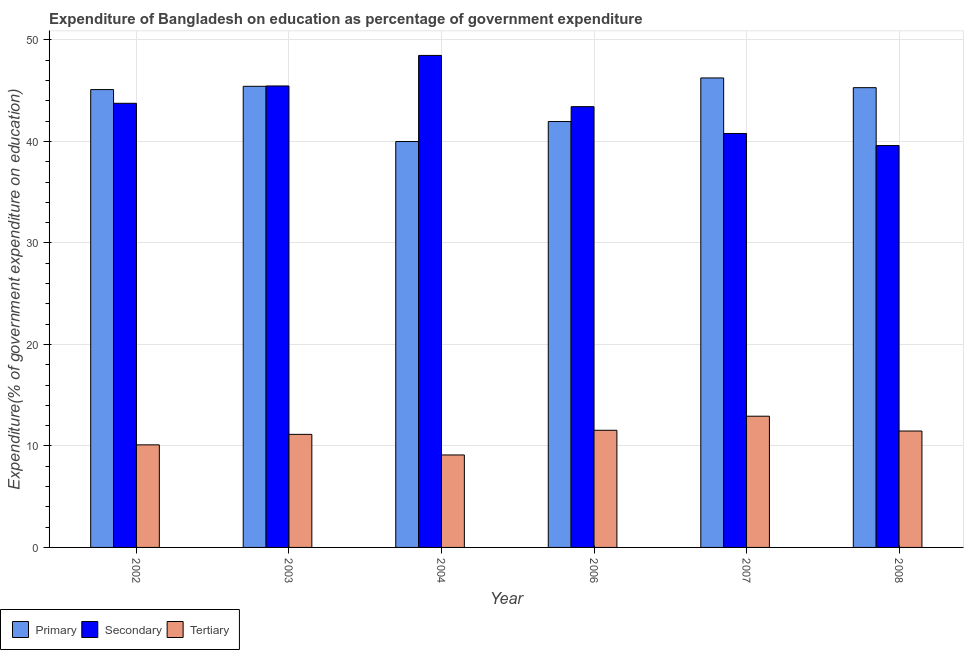How many different coloured bars are there?
Provide a succinct answer. 3. How many groups of bars are there?
Offer a very short reply. 6. Are the number of bars per tick equal to the number of legend labels?
Ensure brevity in your answer.  Yes. How many bars are there on the 3rd tick from the left?
Your answer should be very brief. 3. How many bars are there on the 1st tick from the right?
Your response must be concise. 3. What is the expenditure on primary education in 2008?
Offer a very short reply. 45.29. Across all years, what is the maximum expenditure on secondary education?
Provide a short and direct response. 48.47. Across all years, what is the minimum expenditure on secondary education?
Provide a succinct answer. 39.59. In which year was the expenditure on tertiary education minimum?
Make the answer very short. 2004. What is the total expenditure on secondary education in the graph?
Your answer should be compact. 261.48. What is the difference between the expenditure on tertiary education in 2004 and that in 2008?
Give a very brief answer. -2.36. What is the difference between the expenditure on secondary education in 2007 and the expenditure on primary education in 2008?
Provide a short and direct response. 1.19. What is the average expenditure on secondary education per year?
Offer a very short reply. 43.58. What is the ratio of the expenditure on tertiary education in 2007 to that in 2008?
Keep it short and to the point. 1.13. Is the difference between the expenditure on tertiary education in 2002 and 2004 greater than the difference between the expenditure on secondary education in 2002 and 2004?
Provide a short and direct response. No. What is the difference between the highest and the second highest expenditure on primary education?
Your answer should be compact. 0.82. What is the difference between the highest and the lowest expenditure on primary education?
Ensure brevity in your answer.  6.26. Is the sum of the expenditure on primary education in 2003 and 2008 greater than the maximum expenditure on secondary education across all years?
Keep it short and to the point. Yes. What does the 2nd bar from the left in 2006 represents?
Offer a very short reply. Secondary. What does the 3rd bar from the right in 2008 represents?
Keep it short and to the point. Primary. Are the values on the major ticks of Y-axis written in scientific E-notation?
Make the answer very short. No. Does the graph contain any zero values?
Provide a short and direct response. No. Does the graph contain grids?
Make the answer very short. Yes. Where does the legend appear in the graph?
Provide a succinct answer. Bottom left. How many legend labels are there?
Your response must be concise. 3. What is the title of the graph?
Keep it short and to the point. Expenditure of Bangladesh on education as percentage of government expenditure. What is the label or title of the Y-axis?
Provide a succinct answer. Expenditure(% of government expenditure on education). What is the Expenditure(% of government expenditure on education) in Primary in 2002?
Give a very brief answer. 45.11. What is the Expenditure(% of government expenditure on education) of Secondary in 2002?
Provide a short and direct response. 43.76. What is the Expenditure(% of government expenditure on education) in Tertiary in 2002?
Give a very brief answer. 10.11. What is the Expenditure(% of government expenditure on education) in Primary in 2003?
Provide a short and direct response. 45.43. What is the Expenditure(% of government expenditure on education) of Secondary in 2003?
Provide a succinct answer. 45.46. What is the Expenditure(% of government expenditure on education) of Tertiary in 2003?
Provide a short and direct response. 11.14. What is the Expenditure(% of government expenditure on education) in Primary in 2004?
Offer a terse response. 39.99. What is the Expenditure(% of government expenditure on education) of Secondary in 2004?
Ensure brevity in your answer.  48.47. What is the Expenditure(% of government expenditure on education) of Tertiary in 2004?
Offer a terse response. 9.11. What is the Expenditure(% of government expenditure on education) of Primary in 2006?
Offer a very short reply. 41.96. What is the Expenditure(% of government expenditure on education) in Secondary in 2006?
Your answer should be compact. 43.42. What is the Expenditure(% of government expenditure on education) of Tertiary in 2006?
Provide a short and direct response. 11.54. What is the Expenditure(% of government expenditure on education) in Primary in 2007?
Your answer should be compact. 46.25. What is the Expenditure(% of government expenditure on education) in Secondary in 2007?
Your answer should be compact. 40.78. What is the Expenditure(% of government expenditure on education) in Tertiary in 2007?
Keep it short and to the point. 12.93. What is the Expenditure(% of government expenditure on education) in Primary in 2008?
Keep it short and to the point. 45.29. What is the Expenditure(% of government expenditure on education) in Secondary in 2008?
Offer a very short reply. 39.59. What is the Expenditure(% of government expenditure on education) in Tertiary in 2008?
Make the answer very short. 11.47. Across all years, what is the maximum Expenditure(% of government expenditure on education) in Primary?
Give a very brief answer. 46.25. Across all years, what is the maximum Expenditure(% of government expenditure on education) of Secondary?
Keep it short and to the point. 48.47. Across all years, what is the maximum Expenditure(% of government expenditure on education) of Tertiary?
Provide a succinct answer. 12.93. Across all years, what is the minimum Expenditure(% of government expenditure on education) of Primary?
Offer a terse response. 39.99. Across all years, what is the minimum Expenditure(% of government expenditure on education) of Secondary?
Your response must be concise. 39.59. Across all years, what is the minimum Expenditure(% of government expenditure on education) of Tertiary?
Offer a very short reply. 9.11. What is the total Expenditure(% of government expenditure on education) in Primary in the graph?
Offer a terse response. 264.02. What is the total Expenditure(% of government expenditure on education) of Secondary in the graph?
Make the answer very short. 261.48. What is the total Expenditure(% of government expenditure on education) of Tertiary in the graph?
Keep it short and to the point. 66.29. What is the difference between the Expenditure(% of government expenditure on education) in Primary in 2002 and that in 2003?
Your response must be concise. -0.32. What is the difference between the Expenditure(% of government expenditure on education) in Secondary in 2002 and that in 2003?
Ensure brevity in your answer.  -1.71. What is the difference between the Expenditure(% of government expenditure on education) of Tertiary in 2002 and that in 2003?
Provide a short and direct response. -1.03. What is the difference between the Expenditure(% of government expenditure on education) of Primary in 2002 and that in 2004?
Provide a short and direct response. 5.12. What is the difference between the Expenditure(% of government expenditure on education) in Secondary in 2002 and that in 2004?
Provide a succinct answer. -4.71. What is the difference between the Expenditure(% of government expenditure on education) of Primary in 2002 and that in 2006?
Make the answer very short. 3.15. What is the difference between the Expenditure(% of government expenditure on education) of Secondary in 2002 and that in 2006?
Your answer should be compact. 0.33. What is the difference between the Expenditure(% of government expenditure on education) of Tertiary in 2002 and that in 2006?
Provide a succinct answer. -1.44. What is the difference between the Expenditure(% of government expenditure on education) of Primary in 2002 and that in 2007?
Provide a succinct answer. -1.15. What is the difference between the Expenditure(% of government expenditure on education) in Secondary in 2002 and that in 2007?
Provide a short and direct response. 2.97. What is the difference between the Expenditure(% of government expenditure on education) of Tertiary in 2002 and that in 2007?
Provide a succinct answer. -2.82. What is the difference between the Expenditure(% of government expenditure on education) of Primary in 2002 and that in 2008?
Keep it short and to the point. -0.19. What is the difference between the Expenditure(% of government expenditure on education) of Secondary in 2002 and that in 2008?
Ensure brevity in your answer.  4.16. What is the difference between the Expenditure(% of government expenditure on education) in Tertiary in 2002 and that in 2008?
Make the answer very short. -1.36. What is the difference between the Expenditure(% of government expenditure on education) in Primary in 2003 and that in 2004?
Provide a succinct answer. 5.44. What is the difference between the Expenditure(% of government expenditure on education) of Secondary in 2003 and that in 2004?
Provide a short and direct response. -3.01. What is the difference between the Expenditure(% of government expenditure on education) of Tertiary in 2003 and that in 2004?
Give a very brief answer. 2.03. What is the difference between the Expenditure(% of government expenditure on education) in Primary in 2003 and that in 2006?
Make the answer very short. 3.47. What is the difference between the Expenditure(% of government expenditure on education) in Secondary in 2003 and that in 2006?
Offer a very short reply. 2.04. What is the difference between the Expenditure(% of government expenditure on education) of Tertiary in 2003 and that in 2006?
Your answer should be compact. -0.4. What is the difference between the Expenditure(% of government expenditure on education) of Primary in 2003 and that in 2007?
Keep it short and to the point. -0.82. What is the difference between the Expenditure(% of government expenditure on education) in Secondary in 2003 and that in 2007?
Make the answer very short. 4.68. What is the difference between the Expenditure(% of government expenditure on education) in Tertiary in 2003 and that in 2007?
Provide a short and direct response. -1.79. What is the difference between the Expenditure(% of government expenditure on education) of Primary in 2003 and that in 2008?
Provide a succinct answer. 0.13. What is the difference between the Expenditure(% of government expenditure on education) of Secondary in 2003 and that in 2008?
Keep it short and to the point. 5.87. What is the difference between the Expenditure(% of government expenditure on education) of Tertiary in 2003 and that in 2008?
Your answer should be compact. -0.33. What is the difference between the Expenditure(% of government expenditure on education) in Primary in 2004 and that in 2006?
Keep it short and to the point. -1.97. What is the difference between the Expenditure(% of government expenditure on education) in Secondary in 2004 and that in 2006?
Your response must be concise. 5.05. What is the difference between the Expenditure(% of government expenditure on education) of Tertiary in 2004 and that in 2006?
Your answer should be compact. -2.43. What is the difference between the Expenditure(% of government expenditure on education) of Primary in 2004 and that in 2007?
Your answer should be compact. -6.26. What is the difference between the Expenditure(% of government expenditure on education) of Secondary in 2004 and that in 2007?
Your response must be concise. 7.69. What is the difference between the Expenditure(% of government expenditure on education) of Tertiary in 2004 and that in 2007?
Your answer should be compact. -3.82. What is the difference between the Expenditure(% of government expenditure on education) in Primary in 2004 and that in 2008?
Offer a very short reply. -5.31. What is the difference between the Expenditure(% of government expenditure on education) of Secondary in 2004 and that in 2008?
Offer a terse response. 8.88. What is the difference between the Expenditure(% of government expenditure on education) of Tertiary in 2004 and that in 2008?
Offer a very short reply. -2.36. What is the difference between the Expenditure(% of government expenditure on education) of Primary in 2006 and that in 2007?
Keep it short and to the point. -4.29. What is the difference between the Expenditure(% of government expenditure on education) in Secondary in 2006 and that in 2007?
Keep it short and to the point. 2.64. What is the difference between the Expenditure(% of government expenditure on education) in Tertiary in 2006 and that in 2007?
Provide a succinct answer. -1.39. What is the difference between the Expenditure(% of government expenditure on education) of Primary in 2006 and that in 2008?
Offer a terse response. -3.34. What is the difference between the Expenditure(% of government expenditure on education) in Secondary in 2006 and that in 2008?
Offer a very short reply. 3.83. What is the difference between the Expenditure(% of government expenditure on education) in Tertiary in 2006 and that in 2008?
Your answer should be very brief. 0.07. What is the difference between the Expenditure(% of government expenditure on education) in Primary in 2007 and that in 2008?
Offer a very short reply. 0.96. What is the difference between the Expenditure(% of government expenditure on education) of Secondary in 2007 and that in 2008?
Provide a short and direct response. 1.19. What is the difference between the Expenditure(% of government expenditure on education) in Tertiary in 2007 and that in 2008?
Provide a succinct answer. 1.46. What is the difference between the Expenditure(% of government expenditure on education) of Primary in 2002 and the Expenditure(% of government expenditure on education) of Secondary in 2003?
Provide a succinct answer. -0.36. What is the difference between the Expenditure(% of government expenditure on education) in Primary in 2002 and the Expenditure(% of government expenditure on education) in Tertiary in 2003?
Your response must be concise. 33.97. What is the difference between the Expenditure(% of government expenditure on education) in Secondary in 2002 and the Expenditure(% of government expenditure on education) in Tertiary in 2003?
Your response must be concise. 32.62. What is the difference between the Expenditure(% of government expenditure on education) in Primary in 2002 and the Expenditure(% of government expenditure on education) in Secondary in 2004?
Your answer should be very brief. -3.37. What is the difference between the Expenditure(% of government expenditure on education) of Primary in 2002 and the Expenditure(% of government expenditure on education) of Tertiary in 2004?
Your answer should be very brief. 36. What is the difference between the Expenditure(% of government expenditure on education) in Secondary in 2002 and the Expenditure(% of government expenditure on education) in Tertiary in 2004?
Your answer should be very brief. 34.65. What is the difference between the Expenditure(% of government expenditure on education) of Primary in 2002 and the Expenditure(% of government expenditure on education) of Secondary in 2006?
Your response must be concise. 1.68. What is the difference between the Expenditure(% of government expenditure on education) of Primary in 2002 and the Expenditure(% of government expenditure on education) of Tertiary in 2006?
Provide a succinct answer. 33.56. What is the difference between the Expenditure(% of government expenditure on education) in Secondary in 2002 and the Expenditure(% of government expenditure on education) in Tertiary in 2006?
Ensure brevity in your answer.  32.21. What is the difference between the Expenditure(% of government expenditure on education) in Primary in 2002 and the Expenditure(% of government expenditure on education) in Secondary in 2007?
Provide a succinct answer. 4.32. What is the difference between the Expenditure(% of government expenditure on education) in Primary in 2002 and the Expenditure(% of government expenditure on education) in Tertiary in 2007?
Your response must be concise. 32.18. What is the difference between the Expenditure(% of government expenditure on education) in Secondary in 2002 and the Expenditure(% of government expenditure on education) in Tertiary in 2007?
Offer a terse response. 30.83. What is the difference between the Expenditure(% of government expenditure on education) of Primary in 2002 and the Expenditure(% of government expenditure on education) of Secondary in 2008?
Ensure brevity in your answer.  5.51. What is the difference between the Expenditure(% of government expenditure on education) of Primary in 2002 and the Expenditure(% of government expenditure on education) of Tertiary in 2008?
Offer a very short reply. 33.64. What is the difference between the Expenditure(% of government expenditure on education) in Secondary in 2002 and the Expenditure(% of government expenditure on education) in Tertiary in 2008?
Your response must be concise. 32.29. What is the difference between the Expenditure(% of government expenditure on education) in Primary in 2003 and the Expenditure(% of government expenditure on education) in Secondary in 2004?
Offer a terse response. -3.04. What is the difference between the Expenditure(% of government expenditure on education) of Primary in 2003 and the Expenditure(% of government expenditure on education) of Tertiary in 2004?
Keep it short and to the point. 36.32. What is the difference between the Expenditure(% of government expenditure on education) of Secondary in 2003 and the Expenditure(% of government expenditure on education) of Tertiary in 2004?
Your answer should be very brief. 36.35. What is the difference between the Expenditure(% of government expenditure on education) of Primary in 2003 and the Expenditure(% of government expenditure on education) of Secondary in 2006?
Keep it short and to the point. 2.01. What is the difference between the Expenditure(% of government expenditure on education) in Primary in 2003 and the Expenditure(% of government expenditure on education) in Tertiary in 2006?
Provide a short and direct response. 33.89. What is the difference between the Expenditure(% of government expenditure on education) in Secondary in 2003 and the Expenditure(% of government expenditure on education) in Tertiary in 2006?
Your answer should be very brief. 33.92. What is the difference between the Expenditure(% of government expenditure on education) in Primary in 2003 and the Expenditure(% of government expenditure on education) in Secondary in 2007?
Provide a succinct answer. 4.65. What is the difference between the Expenditure(% of government expenditure on education) in Primary in 2003 and the Expenditure(% of government expenditure on education) in Tertiary in 2007?
Give a very brief answer. 32.5. What is the difference between the Expenditure(% of government expenditure on education) in Secondary in 2003 and the Expenditure(% of government expenditure on education) in Tertiary in 2007?
Offer a very short reply. 32.53. What is the difference between the Expenditure(% of government expenditure on education) in Primary in 2003 and the Expenditure(% of government expenditure on education) in Secondary in 2008?
Your response must be concise. 5.84. What is the difference between the Expenditure(% of government expenditure on education) of Primary in 2003 and the Expenditure(% of government expenditure on education) of Tertiary in 2008?
Your response must be concise. 33.96. What is the difference between the Expenditure(% of government expenditure on education) of Secondary in 2003 and the Expenditure(% of government expenditure on education) of Tertiary in 2008?
Keep it short and to the point. 33.99. What is the difference between the Expenditure(% of government expenditure on education) in Primary in 2004 and the Expenditure(% of government expenditure on education) in Secondary in 2006?
Your response must be concise. -3.44. What is the difference between the Expenditure(% of government expenditure on education) in Primary in 2004 and the Expenditure(% of government expenditure on education) in Tertiary in 2006?
Keep it short and to the point. 28.45. What is the difference between the Expenditure(% of government expenditure on education) in Secondary in 2004 and the Expenditure(% of government expenditure on education) in Tertiary in 2006?
Provide a short and direct response. 36.93. What is the difference between the Expenditure(% of government expenditure on education) of Primary in 2004 and the Expenditure(% of government expenditure on education) of Secondary in 2007?
Provide a short and direct response. -0.79. What is the difference between the Expenditure(% of government expenditure on education) of Primary in 2004 and the Expenditure(% of government expenditure on education) of Tertiary in 2007?
Your response must be concise. 27.06. What is the difference between the Expenditure(% of government expenditure on education) in Secondary in 2004 and the Expenditure(% of government expenditure on education) in Tertiary in 2007?
Keep it short and to the point. 35.54. What is the difference between the Expenditure(% of government expenditure on education) of Primary in 2004 and the Expenditure(% of government expenditure on education) of Secondary in 2008?
Offer a very short reply. 0.4. What is the difference between the Expenditure(% of government expenditure on education) in Primary in 2004 and the Expenditure(% of government expenditure on education) in Tertiary in 2008?
Your answer should be very brief. 28.52. What is the difference between the Expenditure(% of government expenditure on education) in Secondary in 2004 and the Expenditure(% of government expenditure on education) in Tertiary in 2008?
Make the answer very short. 37. What is the difference between the Expenditure(% of government expenditure on education) of Primary in 2006 and the Expenditure(% of government expenditure on education) of Secondary in 2007?
Your answer should be compact. 1.17. What is the difference between the Expenditure(% of government expenditure on education) of Primary in 2006 and the Expenditure(% of government expenditure on education) of Tertiary in 2007?
Give a very brief answer. 29.03. What is the difference between the Expenditure(% of government expenditure on education) in Secondary in 2006 and the Expenditure(% of government expenditure on education) in Tertiary in 2007?
Offer a terse response. 30.49. What is the difference between the Expenditure(% of government expenditure on education) in Primary in 2006 and the Expenditure(% of government expenditure on education) in Secondary in 2008?
Make the answer very short. 2.37. What is the difference between the Expenditure(% of government expenditure on education) in Primary in 2006 and the Expenditure(% of government expenditure on education) in Tertiary in 2008?
Offer a very short reply. 30.49. What is the difference between the Expenditure(% of government expenditure on education) in Secondary in 2006 and the Expenditure(% of government expenditure on education) in Tertiary in 2008?
Your answer should be very brief. 31.95. What is the difference between the Expenditure(% of government expenditure on education) of Primary in 2007 and the Expenditure(% of government expenditure on education) of Secondary in 2008?
Ensure brevity in your answer.  6.66. What is the difference between the Expenditure(% of government expenditure on education) of Primary in 2007 and the Expenditure(% of government expenditure on education) of Tertiary in 2008?
Your answer should be compact. 34.78. What is the difference between the Expenditure(% of government expenditure on education) in Secondary in 2007 and the Expenditure(% of government expenditure on education) in Tertiary in 2008?
Your response must be concise. 29.31. What is the average Expenditure(% of government expenditure on education) of Primary per year?
Offer a terse response. 44. What is the average Expenditure(% of government expenditure on education) of Secondary per year?
Provide a short and direct response. 43.58. What is the average Expenditure(% of government expenditure on education) in Tertiary per year?
Your response must be concise. 11.05. In the year 2002, what is the difference between the Expenditure(% of government expenditure on education) in Primary and Expenditure(% of government expenditure on education) in Secondary?
Offer a terse response. 1.35. In the year 2002, what is the difference between the Expenditure(% of government expenditure on education) in Primary and Expenditure(% of government expenditure on education) in Tertiary?
Your response must be concise. 35. In the year 2002, what is the difference between the Expenditure(% of government expenditure on education) of Secondary and Expenditure(% of government expenditure on education) of Tertiary?
Ensure brevity in your answer.  33.65. In the year 2003, what is the difference between the Expenditure(% of government expenditure on education) in Primary and Expenditure(% of government expenditure on education) in Secondary?
Offer a very short reply. -0.03. In the year 2003, what is the difference between the Expenditure(% of government expenditure on education) of Primary and Expenditure(% of government expenditure on education) of Tertiary?
Your answer should be very brief. 34.29. In the year 2003, what is the difference between the Expenditure(% of government expenditure on education) in Secondary and Expenditure(% of government expenditure on education) in Tertiary?
Your response must be concise. 34.32. In the year 2004, what is the difference between the Expenditure(% of government expenditure on education) in Primary and Expenditure(% of government expenditure on education) in Secondary?
Offer a terse response. -8.48. In the year 2004, what is the difference between the Expenditure(% of government expenditure on education) of Primary and Expenditure(% of government expenditure on education) of Tertiary?
Your answer should be compact. 30.88. In the year 2004, what is the difference between the Expenditure(% of government expenditure on education) of Secondary and Expenditure(% of government expenditure on education) of Tertiary?
Keep it short and to the point. 39.36. In the year 2006, what is the difference between the Expenditure(% of government expenditure on education) of Primary and Expenditure(% of government expenditure on education) of Secondary?
Provide a succinct answer. -1.47. In the year 2006, what is the difference between the Expenditure(% of government expenditure on education) in Primary and Expenditure(% of government expenditure on education) in Tertiary?
Your answer should be compact. 30.41. In the year 2006, what is the difference between the Expenditure(% of government expenditure on education) of Secondary and Expenditure(% of government expenditure on education) of Tertiary?
Provide a succinct answer. 31.88. In the year 2007, what is the difference between the Expenditure(% of government expenditure on education) of Primary and Expenditure(% of government expenditure on education) of Secondary?
Ensure brevity in your answer.  5.47. In the year 2007, what is the difference between the Expenditure(% of government expenditure on education) in Primary and Expenditure(% of government expenditure on education) in Tertiary?
Your answer should be very brief. 33.32. In the year 2007, what is the difference between the Expenditure(% of government expenditure on education) in Secondary and Expenditure(% of government expenditure on education) in Tertiary?
Offer a very short reply. 27.85. In the year 2008, what is the difference between the Expenditure(% of government expenditure on education) of Primary and Expenditure(% of government expenditure on education) of Secondary?
Provide a succinct answer. 5.7. In the year 2008, what is the difference between the Expenditure(% of government expenditure on education) in Primary and Expenditure(% of government expenditure on education) in Tertiary?
Your response must be concise. 33.83. In the year 2008, what is the difference between the Expenditure(% of government expenditure on education) of Secondary and Expenditure(% of government expenditure on education) of Tertiary?
Ensure brevity in your answer.  28.12. What is the ratio of the Expenditure(% of government expenditure on education) in Primary in 2002 to that in 2003?
Ensure brevity in your answer.  0.99. What is the ratio of the Expenditure(% of government expenditure on education) of Secondary in 2002 to that in 2003?
Your response must be concise. 0.96. What is the ratio of the Expenditure(% of government expenditure on education) in Tertiary in 2002 to that in 2003?
Your answer should be very brief. 0.91. What is the ratio of the Expenditure(% of government expenditure on education) of Primary in 2002 to that in 2004?
Provide a succinct answer. 1.13. What is the ratio of the Expenditure(% of government expenditure on education) of Secondary in 2002 to that in 2004?
Make the answer very short. 0.9. What is the ratio of the Expenditure(% of government expenditure on education) of Tertiary in 2002 to that in 2004?
Your response must be concise. 1.11. What is the ratio of the Expenditure(% of government expenditure on education) in Primary in 2002 to that in 2006?
Make the answer very short. 1.07. What is the ratio of the Expenditure(% of government expenditure on education) of Secondary in 2002 to that in 2006?
Your response must be concise. 1.01. What is the ratio of the Expenditure(% of government expenditure on education) of Tertiary in 2002 to that in 2006?
Offer a terse response. 0.88. What is the ratio of the Expenditure(% of government expenditure on education) in Primary in 2002 to that in 2007?
Make the answer very short. 0.98. What is the ratio of the Expenditure(% of government expenditure on education) of Secondary in 2002 to that in 2007?
Your answer should be very brief. 1.07. What is the ratio of the Expenditure(% of government expenditure on education) of Tertiary in 2002 to that in 2007?
Provide a short and direct response. 0.78. What is the ratio of the Expenditure(% of government expenditure on education) in Primary in 2002 to that in 2008?
Make the answer very short. 1. What is the ratio of the Expenditure(% of government expenditure on education) in Secondary in 2002 to that in 2008?
Offer a very short reply. 1.11. What is the ratio of the Expenditure(% of government expenditure on education) in Tertiary in 2002 to that in 2008?
Give a very brief answer. 0.88. What is the ratio of the Expenditure(% of government expenditure on education) of Primary in 2003 to that in 2004?
Keep it short and to the point. 1.14. What is the ratio of the Expenditure(% of government expenditure on education) in Secondary in 2003 to that in 2004?
Offer a very short reply. 0.94. What is the ratio of the Expenditure(% of government expenditure on education) in Tertiary in 2003 to that in 2004?
Your answer should be very brief. 1.22. What is the ratio of the Expenditure(% of government expenditure on education) of Primary in 2003 to that in 2006?
Provide a succinct answer. 1.08. What is the ratio of the Expenditure(% of government expenditure on education) in Secondary in 2003 to that in 2006?
Offer a very short reply. 1.05. What is the ratio of the Expenditure(% of government expenditure on education) in Tertiary in 2003 to that in 2006?
Offer a terse response. 0.97. What is the ratio of the Expenditure(% of government expenditure on education) in Primary in 2003 to that in 2007?
Offer a terse response. 0.98. What is the ratio of the Expenditure(% of government expenditure on education) of Secondary in 2003 to that in 2007?
Provide a short and direct response. 1.11. What is the ratio of the Expenditure(% of government expenditure on education) in Tertiary in 2003 to that in 2007?
Your answer should be compact. 0.86. What is the ratio of the Expenditure(% of government expenditure on education) of Secondary in 2003 to that in 2008?
Offer a terse response. 1.15. What is the ratio of the Expenditure(% of government expenditure on education) of Tertiary in 2003 to that in 2008?
Your answer should be very brief. 0.97. What is the ratio of the Expenditure(% of government expenditure on education) in Primary in 2004 to that in 2006?
Offer a very short reply. 0.95. What is the ratio of the Expenditure(% of government expenditure on education) of Secondary in 2004 to that in 2006?
Offer a very short reply. 1.12. What is the ratio of the Expenditure(% of government expenditure on education) in Tertiary in 2004 to that in 2006?
Your answer should be very brief. 0.79. What is the ratio of the Expenditure(% of government expenditure on education) in Primary in 2004 to that in 2007?
Your answer should be compact. 0.86. What is the ratio of the Expenditure(% of government expenditure on education) in Secondary in 2004 to that in 2007?
Provide a short and direct response. 1.19. What is the ratio of the Expenditure(% of government expenditure on education) in Tertiary in 2004 to that in 2007?
Offer a terse response. 0.7. What is the ratio of the Expenditure(% of government expenditure on education) of Primary in 2004 to that in 2008?
Your answer should be compact. 0.88. What is the ratio of the Expenditure(% of government expenditure on education) in Secondary in 2004 to that in 2008?
Make the answer very short. 1.22. What is the ratio of the Expenditure(% of government expenditure on education) in Tertiary in 2004 to that in 2008?
Keep it short and to the point. 0.79. What is the ratio of the Expenditure(% of government expenditure on education) in Primary in 2006 to that in 2007?
Provide a succinct answer. 0.91. What is the ratio of the Expenditure(% of government expenditure on education) of Secondary in 2006 to that in 2007?
Make the answer very short. 1.06. What is the ratio of the Expenditure(% of government expenditure on education) in Tertiary in 2006 to that in 2007?
Make the answer very short. 0.89. What is the ratio of the Expenditure(% of government expenditure on education) of Primary in 2006 to that in 2008?
Give a very brief answer. 0.93. What is the ratio of the Expenditure(% of government expenditure on education) of Secondary in 2006 to that in 2008?
Provide a succinct answer. 1.1. What is the ratio of the Expenditure(% of government expenditure on education) in Tertiary in 2006 to that in 2008?
Offer a very short reply. 1.01. What is the ratio of the Expenditure(% of government expenditure on education) in Primary in 2007 to that in 2008?
Make the answer very short. 1.02. What is the ratio of the Expenditure(% of government expenditure on education) of Secondary in 2007 to that in 2008?
Your response must be concise. 1.03. What is the ratio of the Expenditure(% of government expenditure on education) of Tertiary in 2007 to that in 2008?
Make the answer very short. 1.13. What is the difference between the highest and the second highest Expenditure(% of government expenditure on education) in Primary?
Provide a short and direct response. 0.82. What is the difference between the highest and the second highest Expenditure(% of government expenditure on education) in Secondary?
Your response must be concise. 3.01. What is the difference between the highest and the second highest Expenditure(% of government expenditure on education) of Tertiary?
Keep it short and to the point. 1.39. What is the difference between the highest and the lowest Expenditure(% of government expenditure on education) in Primary?
Ensure brevity in your answer.  6.26. What is the difference between the highest and the lowest Expenditure(% of government expenditure on education) in Secondary?
Provide a short and direct response. 8.88. What is the difference between the highest and the lowest Expenditure(% of government expenditure on education) in Tertiary?
Your answer should be very brief. 3.82. 